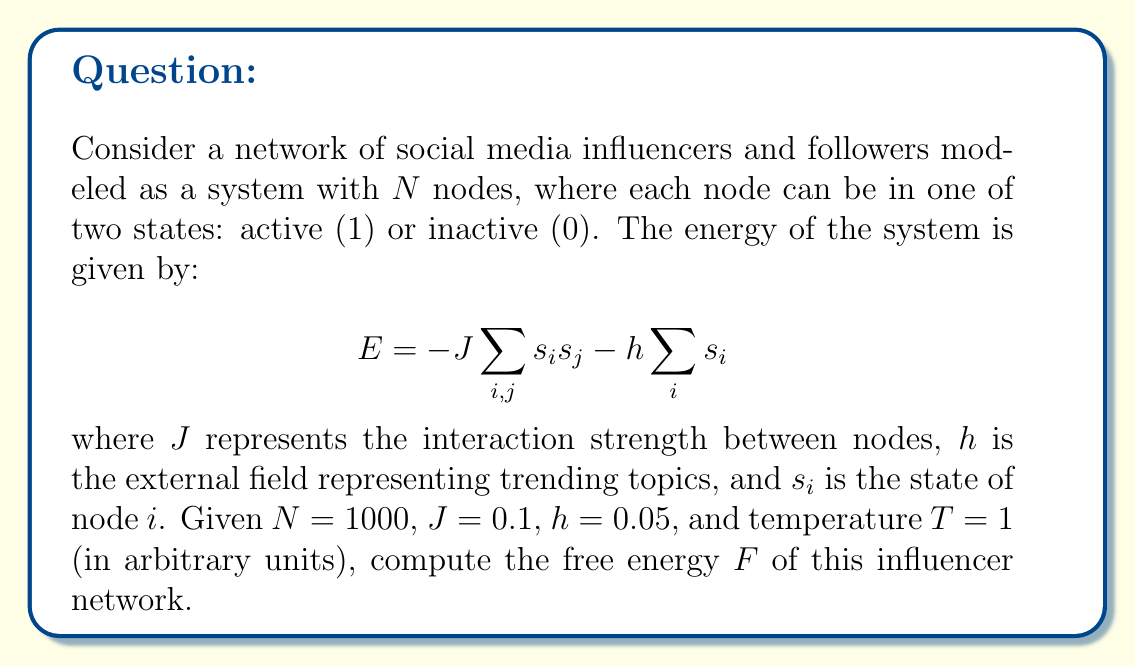Give your solution to this math problem. To solve this problem, we'll use the mean-field approximation for the Ising model, which is applicable to our influencer network. Here's the step-by-step solution:

1) In the mean-field approximation, we assume each node interacts with the average state of all other nodes. Let $m$ be the average state (magnetization):

   $$m = \frac{1}{N} \sum_i s_i$$

2) The mean-field free energy per node is given by:

   $$f = -\frac{1}{2}Jm^2 - hm - T \cdot s(m)$$

   where $s(m)$ is the entropy per node.

3) The entropy $s(m)$ is:

   $$s(m) = -\frac{1+m}{2} \ln\left(\frac{1+m}{2}\right) - \frac{1-m}{2} \ln\left(\frac{1-m}{2}\right)$$

4) To find $m$, we need to solve the self-consistency equation:

   $$m = \tanh(\beta(Jm + h))$$

   where $\beta = 1/T = 1$ in our case.

5) We can solve this numerically. Using an iterative method or a numerical solver, we find:

   $$m \approx 0.0998$$

6) Now we can calculate the free energy per node:

   $$f = -\frac{1}{2} \cdot 0.1 \cdot 0.0998^2 - 0.05 \cdot 0.0998 - 1 \cdot s(0.0998)$$

7) Calculate $s(0.0998)$:

   $$s(0.0998) \approx -0.6951$$

8) Substituting back:

   $$f \approx -0.0005 - 0.00499 + 0.6951 = 0.6896$$

9) The total free energy is $F = N \cdot f$:

   $$F = 1000 \cdot 0.6896 = 689.6$$
Answer: $F \approx 689.6$ (in arbitrary energy units) 